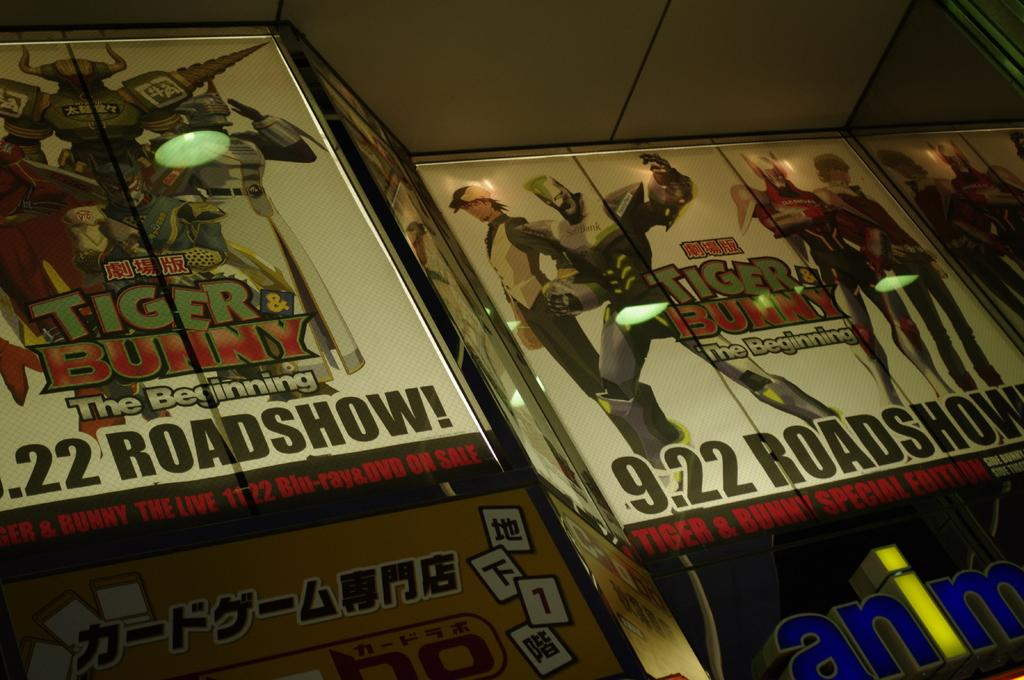Provide a one-sentence caption for the provided image. Two posters show the Tiger and Bunny anime series comes out on September 22nd. 